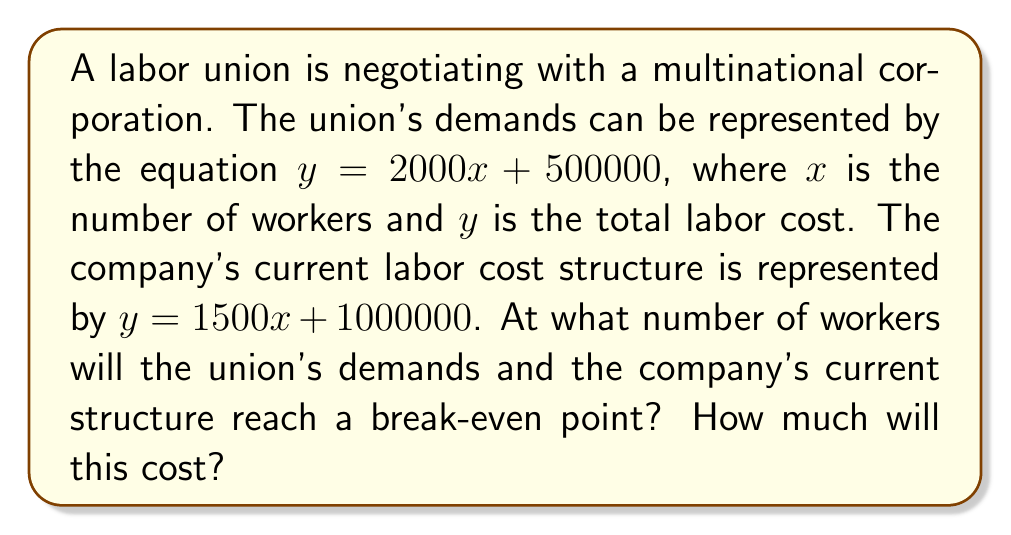Teach me how to tackle this problem. To solve this problem, we need to find the point of intersection between the two linear equations. This represents the break-even point where the union's demands and the company's current structure align.

1. Set up the system of equations:
   $$y = 2000x + 500000$$ (Union's demands)
   $$y = 1500x + 1000000$$ (Company's current structure)

2. Since both equations equal $y$, we can set them equal to each other:
   $$2000x + 500000 = 1500x + 1000000$$

3. Solve for $x$:
   $$2000x - 1500x = 1000000 - 500000$$
   $$500x = 500000$$
   $$x = 1000$$

4. Now that we know the number of workers ($x = 1000$), we can substitute this value into either equation to find the cost ($y$). Let's use the union's demand equation:

   $$y = 2000(1000) + 500000$$
   $$y = 2000000 + 500000$$
   $$y = 2500000$$

Therefore, the break-even point occurs at 1000 workers, with a total labor cost of $2,500,000.
Answer: 1000 workers; $2,500,000 